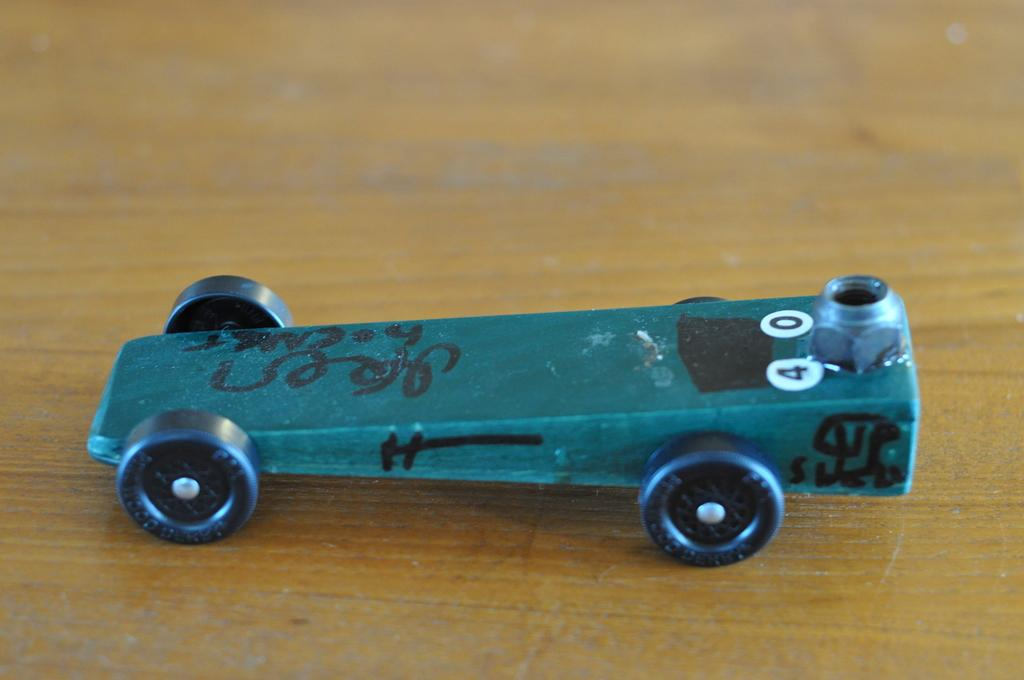What object can be seen in the image? There is a toy in the image. Where is the toy located? The toy is on a wooden platform. What type of sweater is the tiger wearing in the image? There is no tiger or sweater present in the image; it features a toy on a wooden platform. 